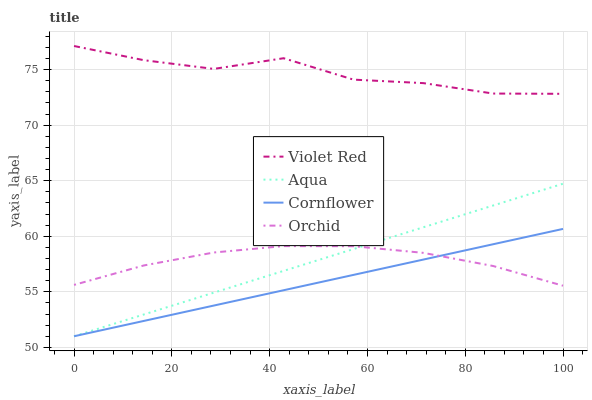Does Cornflower have the minimum area under the curve?
Answer yes or no. Yes. Does Violet Red have the maximum area under the curve?
Answer yes or no. Yes. Does Aqua have the minimum area under the curve?
Answer yes or no. No. Does Aqua have the maximum area under the curve?
Answer yes or no. No. Is Aqua the smoothest?
Answer yes or no. Yes. Is Violet Red the roughest?
Answer yes or no. Yes. Is Violet Red the smoothest?
Answer yes or no. No. Is Aqua the roughest?
Answer yes or no. No. Does Violet Red have the lowest value?
Answer yes or no. No. Does Violet Red have the highest value?
Answer yes or no. Yes. Does Aqua have the highest value?
Answer yes or no. No. Is Orchid less than Violet Red?
Answer yes or no. Yes. Is Violet Red greater than Orchid?
Answer yes or no. Yes. Does Cornflower intersect Aqua?
Answer yes or no. Yes. Is Cornflower less than Aqua?
Answer yes or no. No. Is Cornflower greater than Aqua?
Answer yes or no. No. Does Orchid intersect Violet Red?
Answer yes or no. No. 